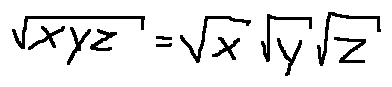<formula> <loc_0><loc_0><loc_500><loc_500>\sqrt { x y z } = \sqrt { x } \sqrt { y } \sqrt { z }</formula> 